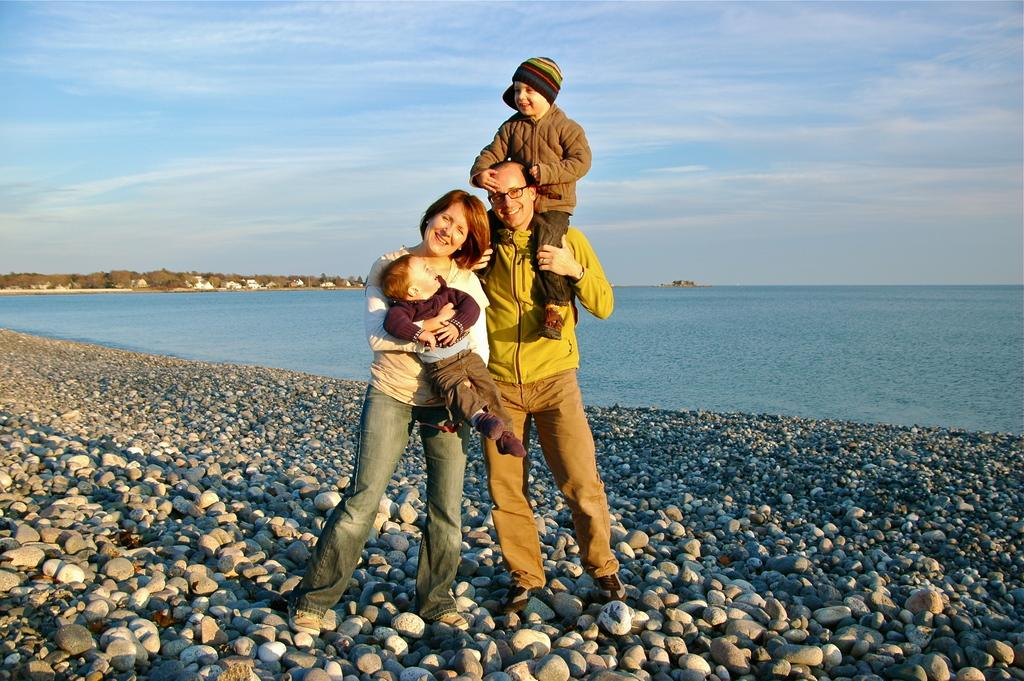What are the people in the image doing? The persons standing in the center of the image are smiling. Can you describe the environment in the image? There is water visible in the background of the image, and there are stones on the ground. What is the condition of the sky in the image? The sky is cloudy in the image. How many pets are visible in the image? There are no pets present in the image. What type of breath can be seen coming from the persons in the image? There is no visible breath in the image, as it is not cold enough for breath to be visible. 